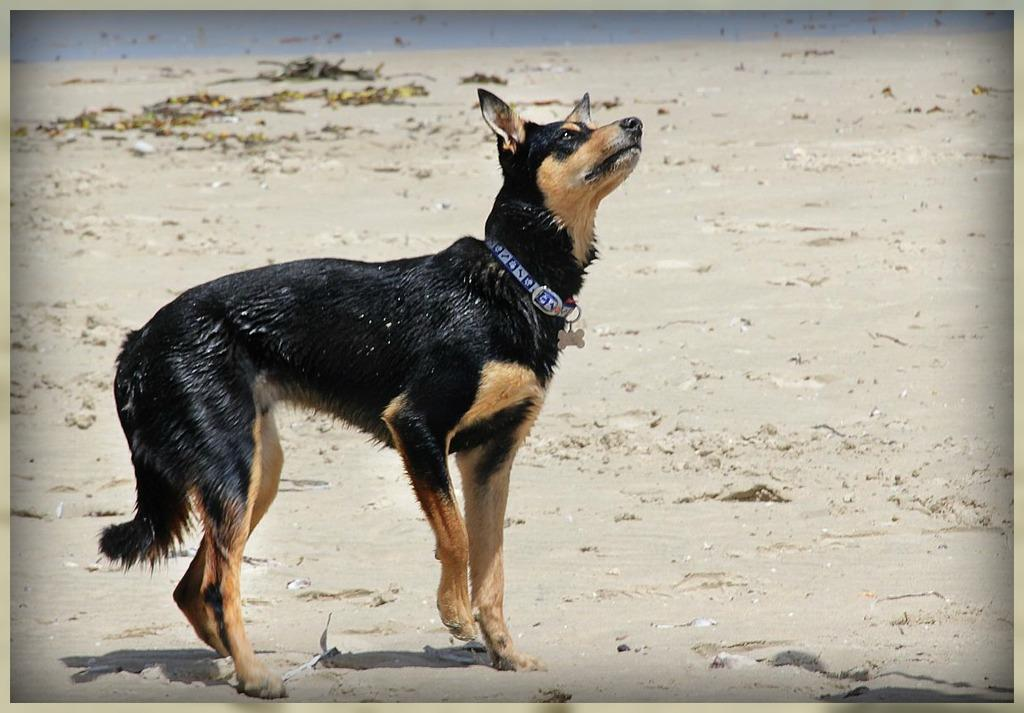What type of animal is in the image? There is a dog in the image. What colors can be seen on the dog? The dog is black and brown in color. Is there any indication that the dog belongs to someone? Yes, the dog has a collar on its neck. Where is the dog standing in the image? The dog is standing on the sand. How many lines can be seen on the dog's ear in the image? There are no lines visible on the dog's ear in the image. 